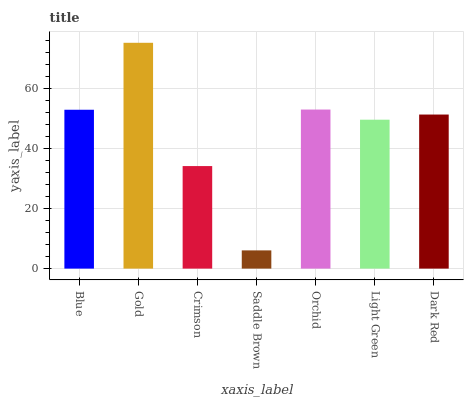Is Saddle Brown the minimum?
Answer yes or no. Yes. Is Gold the maximum?
Answer yes or no. Yes. Is Crimson the minimum?
Answer yes or no. No. Is Crimson the maximum?
Answer yes or no. No. Is Gold greater than Crimson?
Answer yes or no. Yes. Is Crimson less than Gold?
Answer yes or no. Yes. Is Crimson greater than Gold?
Answer yes or no. No. Is Gold less than Crimson?
Answer yes or no. No. Is Dark Red the high median?
Answer yes or no. Yes. Is Dark Red the low median?
Answer yes or no. Yes. Is Gold the high median?
Answer yes or no. No. Is Light Green the low median?
Answer yes or no. No. 